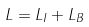<formula> <loc_0><loc_0><loc_500><loc_500>L = L _ { I } + L _ { B }</formula> 